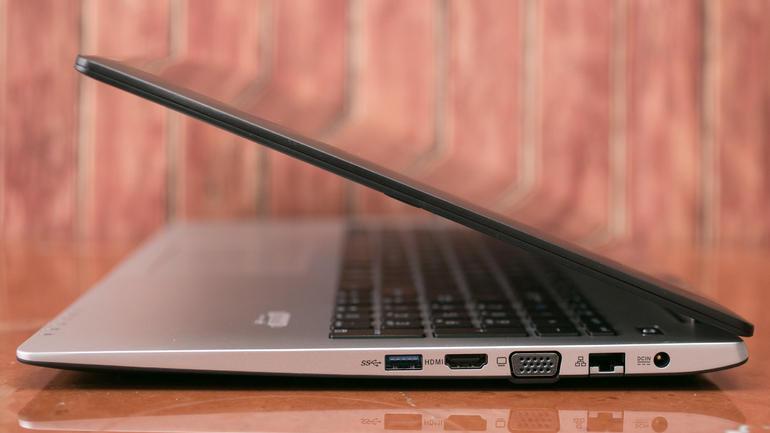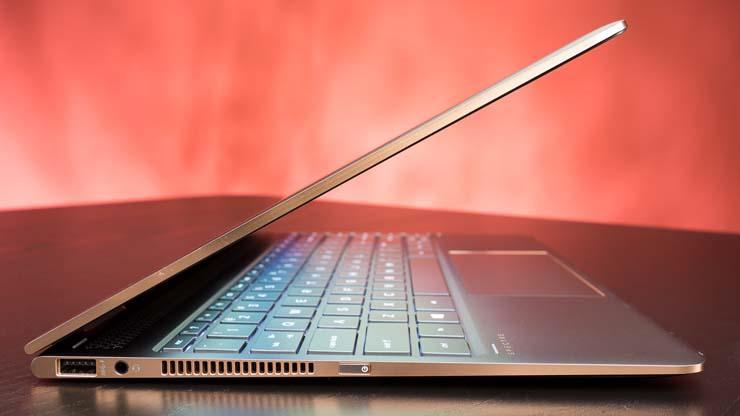The first image is the image on the left, the second image is the image on the right. Assess this claim about the two images: "At least one image shows a straight-on side view of a laptop that is opened at less than a 45-degree angle.". Correct or not? Answer yes or no. Yes. The first image is the image on the left, the second image is the image on the right. For the images displayed, is the sentence "Two laptop computers are only partially opened, not far enough for a person to use, but far enough to see each has a full keyboard, and below it, a touch pad." factually correct? Answer yes or no. Yes. 